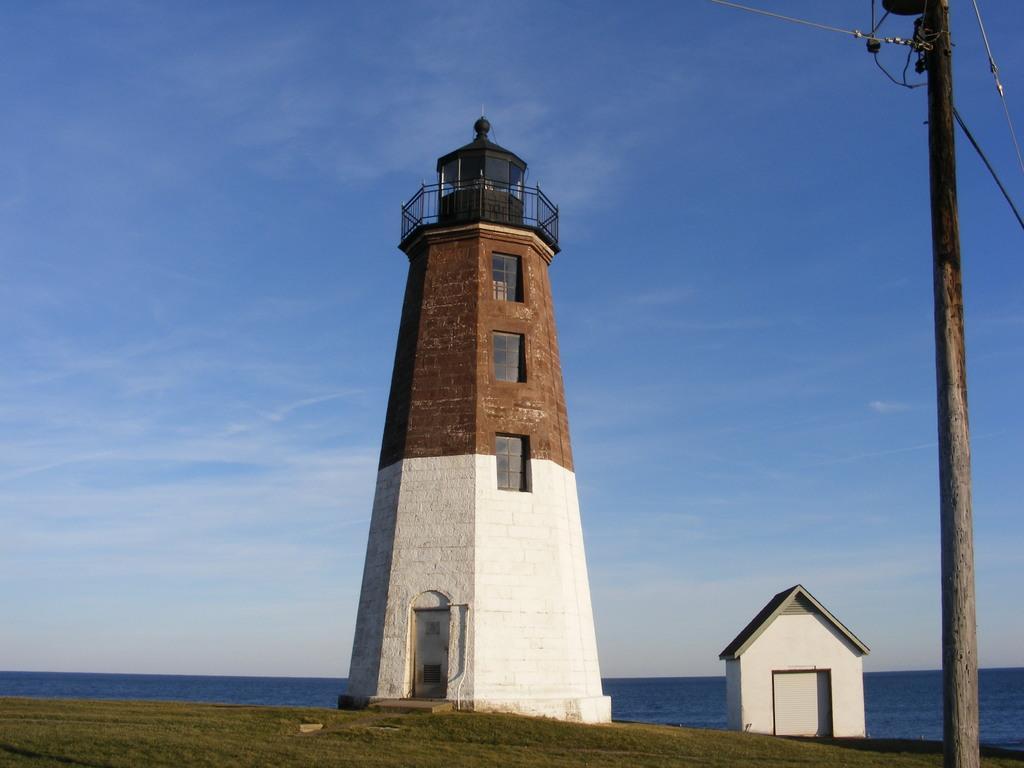Describe this image in one or two sentences. This is an outside view. I can see the grass on the ground. On the right side there is a pole and a house. In the middle of the image there is a tower. In the background, I can see an ocean. At the top of the image I can see the sky. 